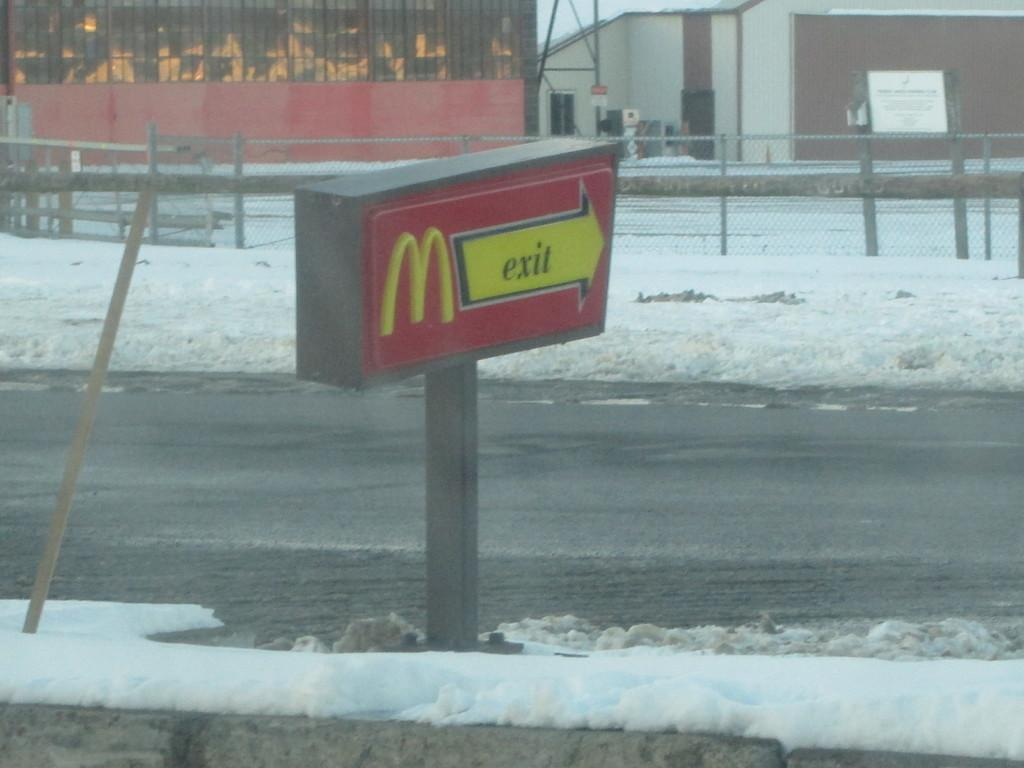<image>
Describe the image concisely. Red and yellow sign which points to the exit for McDonalds. 